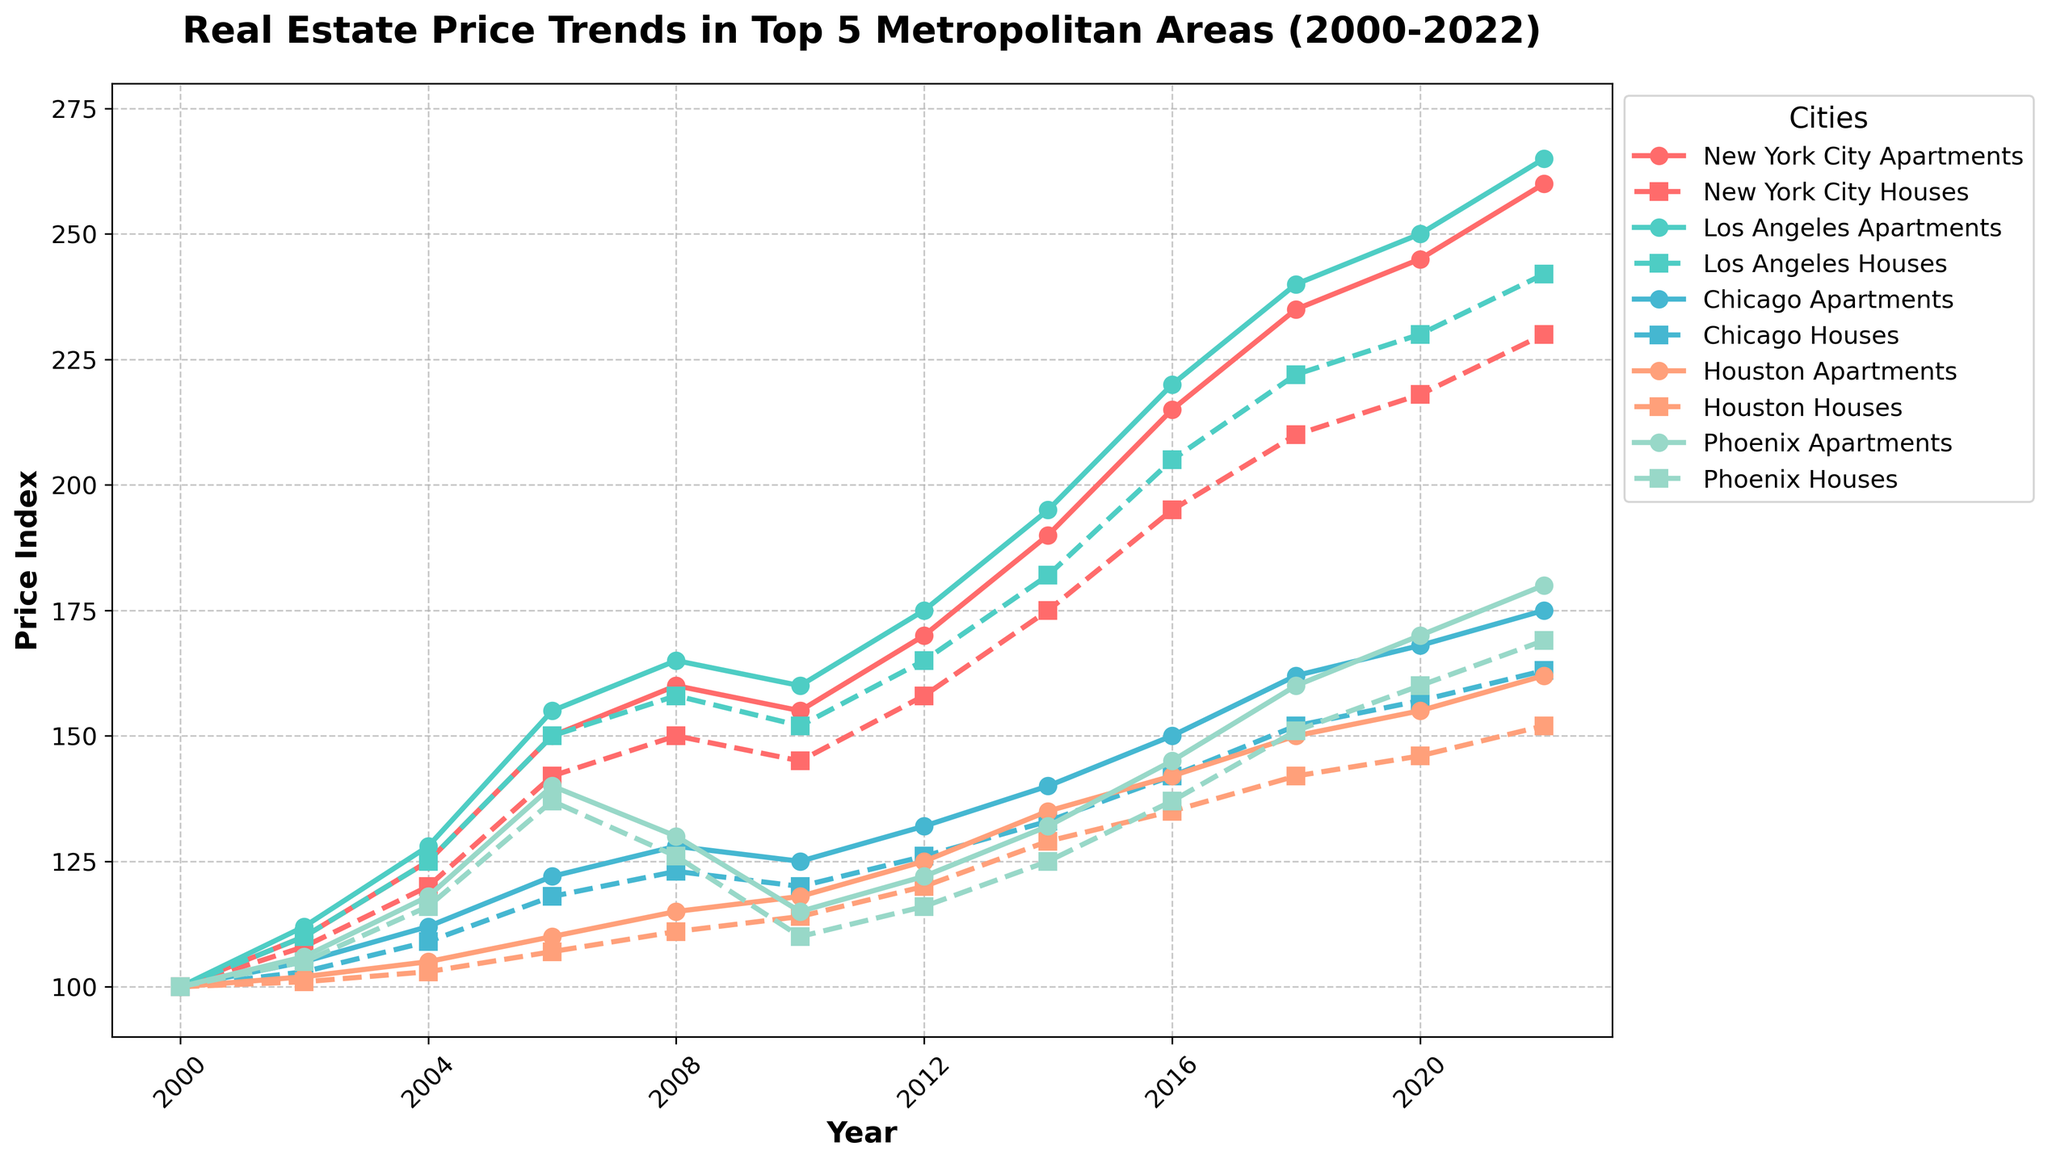What was the price index for Los Angeles Apartments in 2014? Locate 2014 on the x-axis, find the line for Los Angeles Apartments (a solid line), and identify the corresponding y-value.
Answer: 195 Between 2016 and 2020, which city had the biggest increase in apartment price index? Compare the difference in apartment price indices for each city between 2016 and 2020 and find which city had the largest increase. San Jose increased from 210 to 250 (40 points), Dallas from 158 to 178 (20 points), and so on.
Answer: San Jose Did Chicago Houses or Phoenix Houses have a higher price index in 2008? Locate 2008 on the x-axis and compare the y-values for the dashed lines representing Chicago Houses and Phoenix Houses.
Answer: Phoenix Houses Which city had the smallest difference between apartment and house prices in 2022? For each city, calculate the absolute difference between the apartment and house price indices in 2022 by looking at their corresponding points. Compare these differences to find the smallest one.
Answer: Houston How have the prices of apartments in New York City changed from 2000 to 2022? Observe the point for New York City Apartments in 2000 and compare it with the point in 2022, noting the increase or decrease in the y-values over time.
Answer: Increased What is the trend for San Antonio Houses from 2000 to 2022? Follow the dashed line representing San Antonio Houses, noting the overall direction and fluctuations from 2000 to 2022.
Answer: Increasing trend In 2010, which city had the lowest apartment price index? Locate 2010 on the x-axis and identify the lowest y-value among the solid lines representing each city's apartment price index.
Answer: Phoenix By how much did Philadelphia Houses price index increase between 2008 and 2022? Subtract the y-value of Philadelphia Houses in 2008 from the y-value in 2022.
Answer: 53 Which city had more stable house prices, Houston or Phoenix? Compare the dashed lines for Houston Houses and Phoenix Houses from 2000 to 2022, noting the variations in y-values.
Answer: Houston What color represents Chicago in the plot? Identify the lines corresponding to Chicago Apartments and Chicago Houses and observe their color.
Answer: Blue 